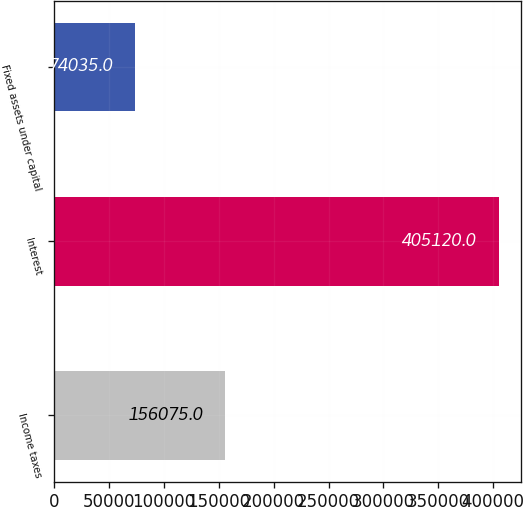Convert chart to OTSL. <chart><loc_0><loc_0><loc_500><loc_500><bar_chart><fcel>Income taxes<fcel>Interest<fcel>Fixed assets under capital<nl><fcel>156075<fcel>405120<fcel>74035<nl></chart> 